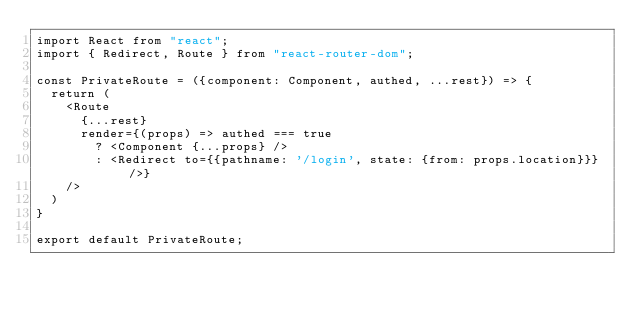<code> <loc_0><loc_0><loc_500><loc_500><_JavaScript_>import React from "react";
import { Redirect, Route } from "react-router-dom";

const PrivateRoute = ({component: Component, authed, ...rest}) => {
  return (
    <Route
      {...rest}
      render={(props) => authed === true
        ? <Component {...props} />
        : <Redirect to={{pathname: '/login', state: {from: props.location}}} />}
    />
  )
}

export default PrivateRoute;
</code> 